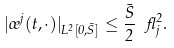Convert formula to latex. <formula><loc_0><loc_0><loc_500><loc_500>| \sigma ^ { j } ( t , \cdot ) | _ { L ^ { 2 } [ 0 , \bar { S } ] } \leq \frac { \bar { S } } { 2 } \ \gamma ^ { 2 } _ { j } .</formula> 